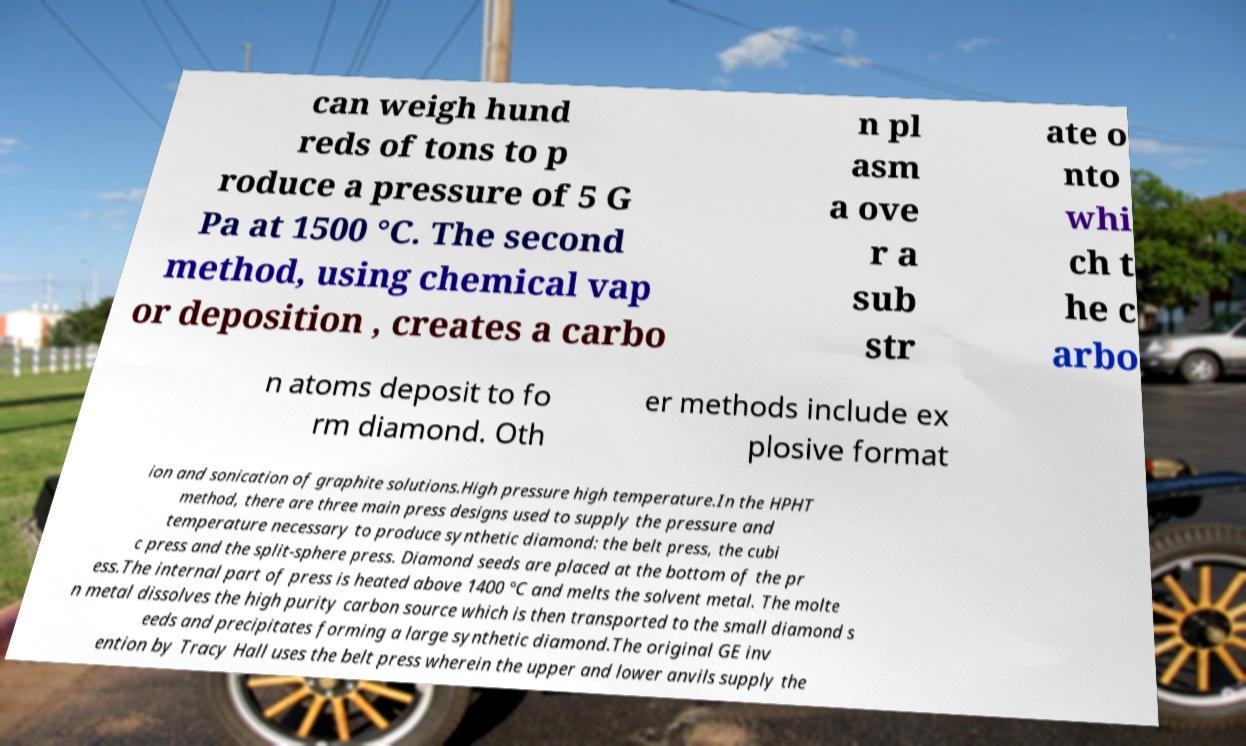Can you accurately transcribe the text from the provided image for me? can weigh hund reds of tons to p roduce a pressure of 5 G Pa at 1500 °C. The second method, using chemical vap or deposition , creates a carbo n pl asm a ove r a sub str ate o nto whi ch t he c arbo n atoms deposit to fo rm diamond. Oth er methods include ex plosive format ion and sonication of graphite solutions.High pressure high temperature.In the HPHT method, there are three main press designs used to supply the pressure and temperature necessary to produce synthetic diamond: the belt press, the cubi c press and the split-sphere press. Diamond seeds are placed at the bottom of the pr ess.The internal part of press is heated above 1400 °C and melts the solvent metal. The molte n metal dissolves the high purity carbon source which is then transported to the small diamond s eeds and precipitates forming a large synthetic diamond.The original GE inv ention by Tracy Hall uses the belt press wherein the upper and lower anvils supply the 